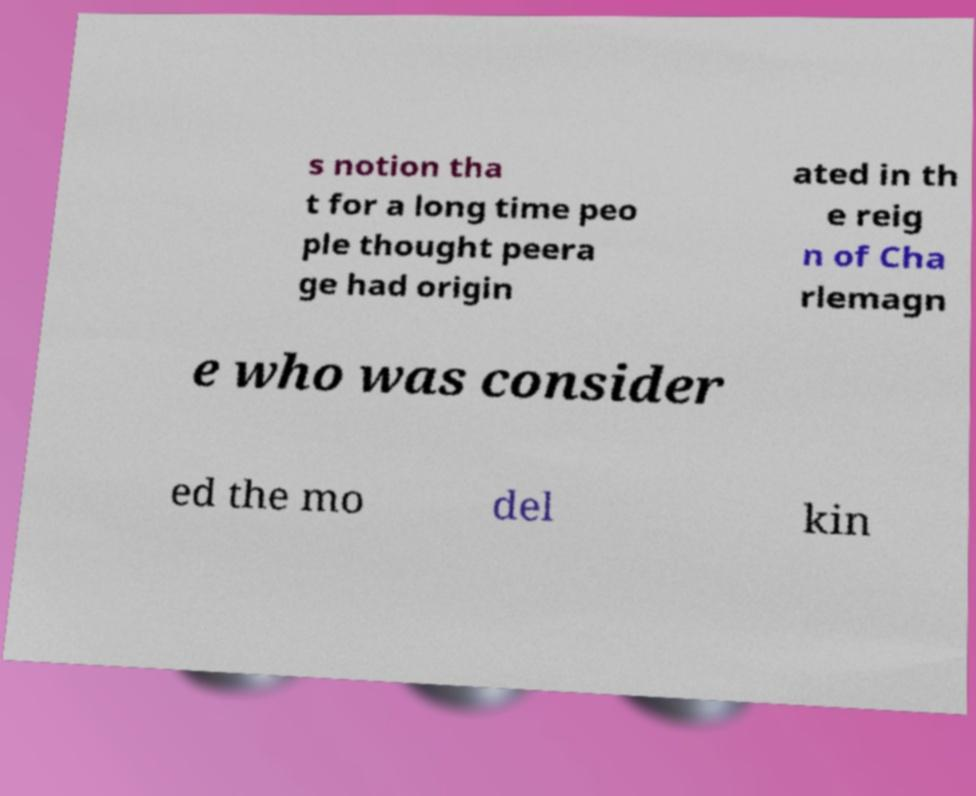I need the written content from this picture converted into text. Can you do that? s notion tha t for a long time peo ple thought peera ge had origin ated in th e reig n of Cha rlemagn e who was consider ed the mo del kin 